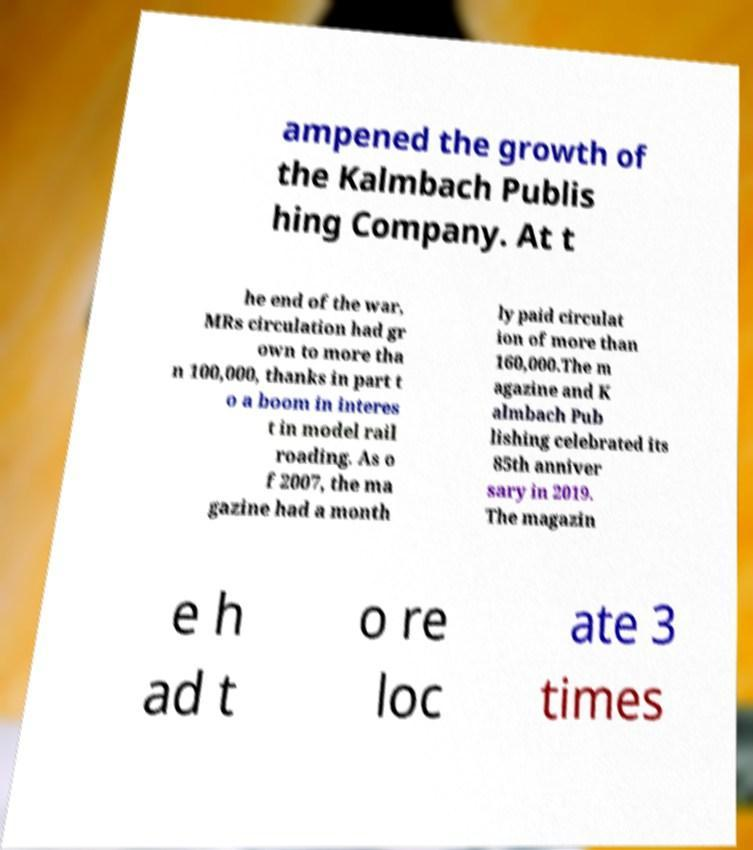For documentation purposes, I need the text within this image transcribed. Could you provide that? ampened the growth of the Kalmbach Publis hing Company. At t he end of the war, MRs circulation had gr own to more tha n 100,000, thanks in part t o a boom in interes t in model rail roading. As o f 2007, the ma gazine had a month ly paid circulat ion of more than 160,000.The m agazine and K almbach Pub lishing celebrated its 85th anniver sary in 2019. The magazin e h ad t o re loc ate 3 times 